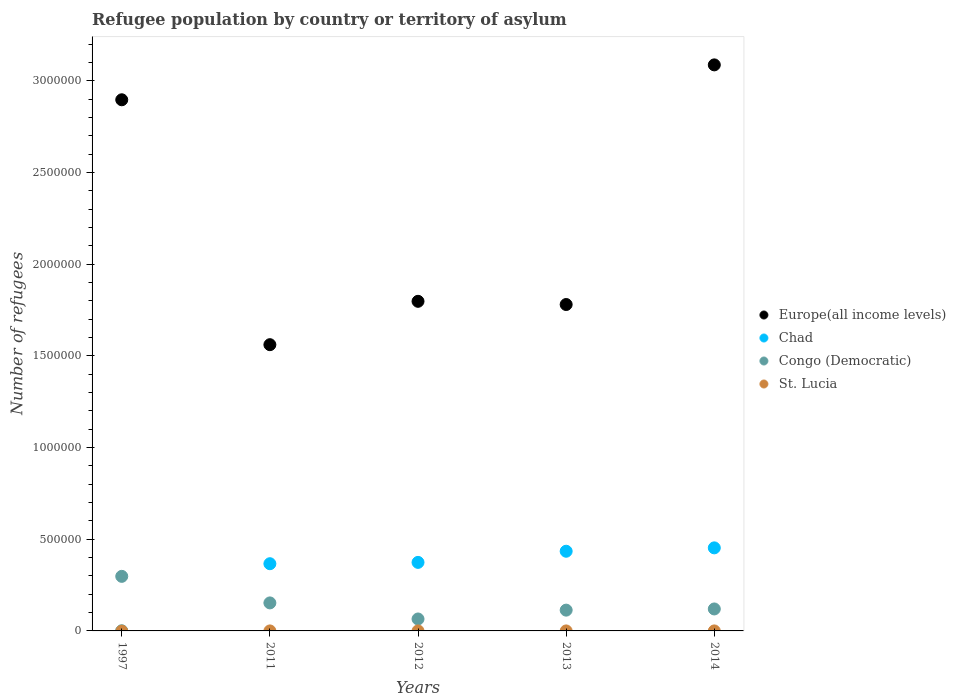How many different coloured dotlines are there?
Ensure brevity in your answer.  4. What is the number of refugees in Chad in 2013?
Provide a succinct answer. 4.34e+05. Across all years, what is the maximum number of refugees in Congo (Democratic)?
Offer a very short reply. 2.98e+05. Across all years, what is the minimum number of refugees in Congo (Democratic)?
Offer a very short reply. 6.51e+04. In which year was the number of refugees in Chad minimum?
Provide a succinct answer. 1997. What is the total number of refugees in Congo (Democratic) in the graph?
Give a very brief answer. 7.49e+05. What is the difference between the number of refugees in Chad in 2011 and that in 2014?
Offer a very short reply. -8.64e+04. What is the difference between the number of refugees in Congo (Democratic) in 2011 and the number of refugees in Europe(all income levels) in 2013?
Your answer should be very brief. -1.63e+06. What is the average number of refugees in St. Lucia per year?
Offer a terse response. 3. In the year 2011, what is the difference between the number of refugees in Congo (Democratic) and number of refugees in St. Lucia?
Your answer should be very brief. 1.53e+05. In how many years, is the number of refugees in Europe(all income levels) greater than 1400000?
Give a very brief answer. 5. What is the ratio of the number of refugees in Congo (Democratic) in 1997 to that in 2013?
Your response must be concise. 2.62. Is the difference between the number of refugees in Congo (Democratic) in 1997 and 2011 greater than the difference between the number of refugees in St. Lucia in 1997 and 2011?
Your response must be concise. Yes. What is the difference between the highest and the second highest number of refugees in Congo (Democratic)?
Ensure brevity in your answer.  1.45e+05. What is the difference between the highest and the lowest number of refugees in Europe(all income levels)?
Your answer should be compact. 1.53e+06. Is the sum of the number of refugees in Congo (Democratic) in 2011 and 2014 greater than the maximum number of refugees in St. Lucia across all years?
Provide a succinct answer. Yes. Is it the case that in every year, the sum of the number of refugees in St. Lucia and number of refugees in Congo (Democratic)  is greater than the sum of number of refugees in Europe(all income levels) and number of refugees in Chad?
Offer a very short reply. Yes. Is it the case that in every year, the sum of the number of refugees in Chad and number of refugees in St. Lucia  is greater than the number of refugees in Europe(all income levels)?
Your response must be concise. No. Is the number of refugees in St. Lucia strictly less than the number of refugees in Congo (Democratic) over the years?
Make the answer very short. Yes. How many years are there in the graph?
Give a very brief answer. 5. What is the difference between two consecutive major ticks on the Y-axis?
Provide a short and direct response. 5.00e+05. Does the graph contain any zero values?
Ensure brevity in your answer.  No. Does the graph contain grids?
Provide a succinct answer. No. Where does the legend appear in the graph?
Give a very brief answer. Center right. How many legend labels are there?
Your response must be concise. 4. What is the title of the graph?
Offer a terse response. Refugee population by country or territory of asylum. Does "Euro area" appear as one of the legend labels in the graph?
Your answer should be very brief. No. What is the label or title of the Y-axis?
Provide a succinct answer. Number of refugees. What is the Number of refugees of Europe(all income levels) in 1997?
Offer a terse response. 2.90e+06. What is the Number of refugees of Chad in 1997?
Offer a terse response. 302. What is the Number of refugees of Congo (Democratic) in 1997?
Your response must be concise. 2.98e+05. What is the Number of refugees in Europe(all income levels) in 2011?
Your answer should be compact. 1.56e+06. What is the Number of refugees of Chad in 2011?
Provide a succinct answer. 3.66e+05. What is the Number of refugees in Congo (Democratic) in 2011?
Offer a very short reply. 1.53e+05. What is the Number of refugees of Europe(all income levels) in 2012?
Your answer should be very brief. 1.80e+06. What is the Number of refugees of Chad in 2012?
Provide a succinct answer. 3.74e+05. What is the Number of refugees in Congo (Democratic) in 2012?
Your answer should be very brief. 6.51e+04. What is the Number of refugees in Europe(all income levels) in 2013?
Your answer should be very brief. 1.78e+06. What is the Number of refugees in Chad in 2013?
Provide a succinct answer. 4.34e+05. What is the Number of refugees in Congo (Democratic) in 2013?
Make the answer very short. 1.13e+05. What is the Number of refugees of St. Lucia in 2013?
Your answer should be very brief. 5. What is the Number of refugees of Europe(all income levels) in 2014?
Provide a succinct answer. 3.09e+06. What is the Number of refugees in Chad in 2014?
Keep it short and to the point. 4.53e+05. What is the Number of refugees in Congo (Democratic) in 2014?
Your answer should be very brief. 1.20e+05. Across all years, what is the maximum Number of refugees in Europe(all income levels)?
Provide a short and direct response. 3.09e+06. Across all years, what is the maximum Number of refugees in Chad?
Your response must be concise. 4.53e+05. Across all years, what is the maximum Number of refugees of Congo (Democratic)?
Keep it short and to the point. 2.98e+05. Across all years, what is the minimum Number of refugees in Europe(all income levels)?
Make the answer very short. 1.56e+06. Across all years, what is the minimum Number of refugees in Chad?
Make the answer very short. 302. Across all years, what is the minimum Number of refugees in Congo (Democratic)?
Provide a succinct answer. 6.51e+04. What is the total Number of refugees in Europe(all income levels) in the graph?
Offer a very short reply. 1.11e+07. What is the total Number of refugees in Chad in the graph?
Give a very brief answer. 1.63e+06. What is the total Number of refugees in Congo (Democratic) in the graph?
Keep it short and to the point. 7.49e+05. What is the total Number of refugees in St. Lucia in the graph?
Your response must be concise. 15. What is the difference between the Number of refugees of Europe(all income levels) in 1997 and that in 2011?
Keep it short and to the point. 1.34e+06. What is the difference between the Number of refugees in Chad in 1997 and that in 2011?
Ensure brevity in your answer.  -3.66e+05. What is the difference between the Number of refugees in Congo (Democratic) in 1997 and that in 2011?
Provide a succinct answer. 1.45e+05. What is the difference between the Number of refugees in St. Lucia in 1997 and that in 2011?
Keep it short and to the point. 1. What is the difference between the Number of refugees of Europe(all income levels) in 1997 and that in 2012?
Ensure brevity in your answer.  1.10e+06. What is the difference between the Number of refugees of Chad in 1997 and that in 2012?
Give a very brief answer. -3.73e+05. What is the difference between the Number of refugees of Congo (Democratic) in 1997 and that in 2012?
Offer a terse response. 2.32e+05. What is the difference between the Number of refugees of St. Lucia in 1997 and that in 2012?
Provide a succinct answer. 1. What is the difference between the Number of refugees of Europe(all income levels) in 1997 and that in 2013?
Provide a succinct answer. 1.12e+06. What is the difference between the Number of refugees of Chad in 1997 and that in 2013?
Offer a terse response. -4.34e+05. What is the difference between the Number of refugees of Congo (Democratic) in 1997 and that in 2013?
Provide a succinct answer. 1.84e+05. What is the difference between the Number of refugees of St. Lucia in 1997 and that in 2013?
Offer a very short reply. -2. What is the difference between the Number of refugees in Europe(all income levels) in 1997 and that in 2014?
Offer a very short reply. -1.90e+05. What is the difference between the Number of refugees of Chad in 1997 and that in 2014?
Your answer should be very brief. -4.53e+05. What is the difference between the Number of refugees of Congo (Democratic) in 1997 and that in 2014?
Keep it short and to the point. 1.78e+05. What is the difference between the Number of refugees of Europe(all income levels) in 2011 and that in 2012?
Provide a short and direct response. -2.36e+05. What is the difference between the Number of refugees in Chad in 2011 and that in 2012?
Provide a short and direct response. -7201. What is the difference between the Number of refugees of Congo (Democratic) in 2011 and that in 2012?
Your answer should be compact. 8.76e+04. What is the difference between the Number of refugees of Europe(all income levels) in 2011 and that in 2013?
Offer a terse response. -2.19e+05. What is the difference between the Number of refugees in Chad in 2011 and that in 2013?
Make the answer very short. -6.80e+04. What is the difference between the Number of refugees of Congo (Democratic) in 2011 and that in 2013?
Provide a succinct answer. 3.94e+04. What is the difference between the Number of refugees in St. Lucia in 2011 and that in 2013?
Ensure brevity in your answer.  -3. What is the difference between the Number of refugees of Europe(all income levels) in 2011 and that in 2014?
Offer a terse response. -1.53e+06. What is the difference between the Number of refugees in Chad in 2011 and that in 2014?
Keep it short and to the point. -8.64e+04. What is the difference between the Number of refugees in Congo (Democratic) in 2011 and that in 2014?
Make the answer very short. 3.30e+04. What is the difference between the Number of refugees of St. Lucia in 2011 and that in 2014?
Give a very brief answer. -1. What is the difference between the Number of refugees in Europe(all income levels) in 2012 and that in 2013?
Your answer should be compact. 1.74e+04. What is the difference between the Number of refugees of Chad in 2012 and that in 2013?
Offer a terse response. -6.08e+04. What is the difference between the Number of refugees of Congo (Democratic) in 2012 and that in 2013?
Offer a very short reply. -4.83e+04. What is the difference between the Number of refugees of St. Lucia in 2012 and that in 2013?
Provide a short and direct response. -3. What is the difference between the Number of refugees of Europe(all income levels) in 2012 and that in 2014?
Make the answer very short. -1.29e+06. What is the difference between the Number of refugees of Chad in 2012 and that in 2014?
Provide a short and direct response. -7.92e+04. What is the difference between the Number of refugees in Congo (Democratic) in 2012 and that in 2014?
Your response must be concise. -5.46e+04. What is the difference between the Number of refugees in Europe(all income levels) in 2013 and that in 2014?
Make the answer very short. -1.31e+06. What is the difference between the Number of refugees of Chad in 2013 and that in 2014?
Give a very brief answer. -1.84e+04. What is the difference between the Number of refugees in Congo (Democratic) in 2013 and that in 2014?
Offer a very short reply. -6392. What is the difference between the Number of refugees of Europe(all income levels) in 1997 and the Number of refugees of Chad in 2011?
Keep it short and to the point. 2.53e+06. What is the difference between the Number of refugees of Europe(all income levels) in 1997 and the Number of refugees of Congo (Democratic) in 2011?
Ensure brevity in your answer.  2.74e+06. What is the difference between the Number of refugees of Europe(all income levels) in 1997 and the Number of refugees of St. Lucia in 2011?
Offer a terse response. 2.90e+06. What is the difference between the Number of refugees in Chad in 1997 and the Number of refugees in Congo (Democratic) in 2011?
Ensure brevity in your answer.  -1.52e+05. What is the difference between the Number of refugees in Chad in 1997 and the Number of refugees in St. Lucia in 2011?
Ensure brevity in your answer.  300. What is the difference between the Number of refugees in Congo (Democratic) in 1997 and the Number of refugees in St. Lucia in 2011?
Ensure brevity in your answer.  2.98e+05. What is the difference between the Number of refugees in Europe(all income levels) in 1997 and the Number of refugees in Chad in 2012?
Your answer should be very brief. 2.52e+06. What is the difference between the Number of refugees in Europe(all income levels) in 1997 and the Number of refugees in Congo (Democratic) in 2012?
Give a very brief answer. 2.83e+06. What is the difference between the Number of refugees in Europe(all income levels) in 1997 and the Number of refugees in St. Lucia in 2012?
Your answer should be compact. 2.90e+06. What is the difference between the Number of refugees in Chad in 1997 and the Number of refugees in Congo (Democratic) in 2012?
Your response must be concise. -6.48e+04. What is the difference between the Number of refugees of Chad in 1997 and the Number of refugees of St. Lucia in 2012?
Your response must be concise. 300. What is the difference between the Number of refugees of Congo (Democratic) in 1997 and the Number of refugees of St. Lucia in 2012?
Offer a terse response. 2.98e+05. What is the difference between the Number of refugees in Europe(all income levels) in 1997 and the Number of refugees in Chad in 2013?
Provide a short and direct response. 2.46e+06. What is the difference between the Number of refugees in Europe(all income levels) in 1997 and the Number of refugees in Congo (Democratic) in 2013?
Offer a very short reply. 2.78e+06. What is the difference between the Number of refugees in Europe(all income levels) in 1997 and the Number of refugees in St. Lucia in 2013?
Offer a very short reply. 2.90e+06. What is the difference between the Number of refugees of Chad in 1997 and the Number of refugees of Congo (Democratic) in 2013?
Make the answer very short. -1.13e+05. What is the difference between the Number of refugees of Chad in 1997 and the Number of refugees of St. Lucia in 2013?
Ensure brevity in your answer.  297. What is the difference between the Number of refugees in Congo (Democratic) in 1997 and the Number of refugees in St. Lucia in 2013?
Offer a very short reply. 2.98e+05. What is the difference between the Number of refugees of Europe(all income levels) in 1997 and the Number of refugees of Chad in 2014?
Offer a terse response. 2.44e+06. What is the difference between the Number of refugees in Europe(all income levels) in 1997 and the Number of refugees in Congo (Democratic) in 2014?
Your response must be concise. 2.78e+06. What is the difference between the Number of refugees of Europe(all income levels) in 1997 and the Number of refugees of St. Lucia in 2014?
Give a very brief answer. 2.90e+06. What is the difference between the Number of refugees in Chad in 1997 and the Number of refugees in Congo (Democratic) in 2014?
Your answer should be compact. -1.19e+05. What is the difference between the Number of refugees in Chad in 1997 and the Number of refugees in St. Lucia in 2014?
Offer a very short reply. 299. What is the difference between the Number of refugees in Congo (Democratic) in 1997 and the Number of refugees in St. Lucia in 2014?
Offer a very short reply. 2.98e+05. What is the difference between the Number of refugees in Europe(all income levels) in 2011 and the Number of refugees in Chad in 2012?
Offer a terse response. 1.19e+06. What is the difference between the Number of refugees in Europe(all income levels) in 2011 and the Number of refugees in Congo (Democratic) in 2012?
Your answer should be very brief. 1.50e+06. What is the difference between the Number of refugees of Europe(all income levels) in 2011 and the Number of refugees of St. Lucia in 2012?
Provide a short and direct response. 1.56e+06. What is the difference between the Number of refugees of Chad in 2011 and the Number of refugees of Congo (Democratic) in 2012?
Offer a terse response. 3.01e+05. What is the difference between the Number of refugees of Chad in 2011 and the Number of refugees of St. Lucia in 2012?
Your answer should be very brief. 3.66e+05. What is the difference between the Number of refugees in Congo (Democratic) in 2011 and the Number of refugees in St. Lucia in 2012?
Make the answer very short. 1.53e+05. What is the difference between the Number of refugees of Europe(all income levels) in 2011 and the Number of refugees of Chad in 2013?
Your response must be concise. 1.13e+06. What is the difference between the Number of refugees in Europe(all income levels) in 2011 and the Number of refugees in Congo (Democratic) in 2013?
Your answer should be compact. 1.45e+06. What is the difference between the Number of refugees in Europe(all income levels) in 2011 and the Number of refugees in St. Lucia in 2013?
Provide a succinct answer. 1.56e+06. What is the difference between the Number of refugees in Chad in 2011 and the Number of refugees in Congo (Democratic) in 2013?
Ensure brevity in your answer.  2.53e+05. What is the difference between the Number of refugees of Chad in 2011 and the Number of refugees of St. Lucia in 2013?
Give a very brief answer. 3.66e+05. What is the difference between the Number of refugees of Congo (Democratic) in 2011 and the Number of refugees of St. Lucia in 2013?
Provide a succinct answer. 1.53e+05. What is the difference between the Number of refugees of Europe(all income levels) in 2011 and the Number of refugees of Chad in 2014?
Make the answer very short. 1.11e+06. What is the difference between the Number of refugees of Europe(all income levels) in 2011 and the Number of refugees of Congo (Democratic) in 2014?
Provide a short and direct response. 1.44e+06. What is the difference between the Number of refugees in Europe(all income levels) in 2011 and the Number of refugees in St. Lucia in 2014?
Offer a terse response. 1.56e+06. What is the difference between the Number of refugees in Chad in 2011 and the Number of refugees in Congo (Democratic) in 2014?
Give a very brief answer. 2.47e+05. What is the difference between the Number of refugees of Chad in 2011 and the Number of refugees of St. Lucia in 2014?
Offer a very short reply. 3.66e+05. What is the difference between the Number of refugees of Congo (Democratic) in 2011 and the Number of refugees of St. Lucia in 2014?
Offer a very short reply. 1.53e+05. What is the difference between the Number of refugees of Europe(all income levels) in 2012 and the Number of refugees of Chad in 2013?
Make the answer very short. 1.36e+06. What is the difference between the Number of refugees in Europe(all income levels) in 2012 and the Number of refugees in Congo (Democratic) in 2013?
Offer a terse response. 1.68e+06. What is the difference between the Number of refugees in Europe(all income levels) in 2012 and the Number of refugees in St. Lucia in 2013?
Offer a very short reply. 1.80e+06. What is the difference between the Number of refugees of Chad in 2012 and the Number of refugees of Congo (Democratic) in 2013?
Provide a short and direct response. 2.60e+05. What is the difference between the Number of refugees of Chad in 2012 and the Number of refugees of St. Lucia in 2013?
Your response must be concise. 3.74e+05. What is the difference between the Number of refugees in Congo (Democratic) in 2012 and the Number of refugees in St. Lucia in 2013?
Offer a very short reply. 6.51e+04. What is the difference between the Number of refugees in Europe(all income levels) in 2012 and the Number of refugees in Chad in 2014?
Your answer should be compact. 1.34e+06. What is the difference between the Number of refugees of Europe(all income levels) in 2012 and the Number of refugees of Congo (Democratic) in 2014?
Make the answer very short. 1.68e+06. What is the difference between the Number of refugees of Europe(all income levels) in 2012 and the Number of refugees of St. Lucia in 2014?
Make the answer very short. 1.80e+06. What is the difference between the Number of refugees in Chad in 2012 and the Number of refugees in Congo (Democratic) in 2014?
Make the answer very short. 2.54e+05. What is the difference between the Number of refugees of Chad in 2012 and the Number of refugees of St. Lucia in 2014?
Offer a very short reply. 3.74e+05. What is the difference between the Number of refugees in Congo (Democratic) in 2012 and the Number of refugees in St. Lucia in 2014?
Your answer should be compact. 6.51e+04. What is the difference between the Number of refugees of Europe(all income levels) in 2013 and the Number of refugees of Chad in 2014?
Make the answer very short. 1.33e+06. What is the difference between the Number of refugees of Europe(all income levels) in 2013 and the Number of refugees of Congo (Democratic) in 2014?
Make the answer very short. 1.66e+06. What is the difference between the Number of refugees of Europe(all income levels) in 2013 and the Number of refugees of St. Lucia in 2014?
Your answer should be very brief. 1.78e+06. What is the difference between the Number of refugees in Chad in 2013 and the Number of refugees in Congo (Democratic) in 2014?
Keep it short and to the point. 3.15e+05. What is the difference between the Number of refugees of Chad in 2013 and the Number of refugees of St. Lucia in 2014?
Your answer should be compact. 4.34e+05. What is the difference between the Number of refugees of Congo (Democratic) in 2013 and the Number of refugees of St. Lucia in 2014?
Keep it short and to the point. 1.13e+05. What is the average Number of refugees of Europe(all income levels) per year?
Your response must be concise. 2.22e+06. What is the average Number of refugees of Chad per year?
Offer a very short reply. 3.26e+05. What is the average Number of refugees in Congo (Democratic) per year?
Provide a short and direct response. 1.50e+05. In the year 1997, what is the difference between the Number of refugees in Europe(all income levels) and Number of refugees in Chad?
Offer a terse response. 2.90e+06. In the year 1997, what is the difference between the Number of refugees of Europe(all income levels) and Number of refugees of Congo (Democratic)?
Provide a short and direct response. 2.60e+06. In the year 1997, what is the difference between the Number of refugees in Europe(all income levels) and Number of refugees in St. Lucia?
Your answer should be compact. 2.90e+06. In the year 1997, what is the difference between the Number of refugees of Chad and Number of refugees of Congo (Democratic)?
Your answer should be very brief. -2.97e+05. In the year 1997, what is the difference between the Number of refugees of Chad and Number of refugees of St. Lucia?
Offer a terse response. 299. In the year 1997, what is the difference between the Number of refugees in Congo (Democratic) and Number of refugees in St. Lucia?
Your answer should be compact. 2.98e+05. In the year 2011, what is the difference between the Number of refugees of Europe(all income levels) and Number of refugees of Chad?
Keep it short and to the point. 1.19e+06. In the year 2011, what is the difference between the Number of refugees in Europe(all income levels) and Number of refugees in Congo (Democratic)?
Provide a succinct answer. 1.41e+06. In the year 2011, what is the difference between the Number of refugees of Europe(all income levels) and Number of refugees of St. Lucia?
Offer a terse response. 1.56e+06. In the year 2011, what is the difference between the Number of refugees in Chad and Number of refugees in Congo (Democratic)?
Offer a very short reply. 2.14e+05. In the year 2011, what is the difference between the Number of refugees in Chad and Number of refugees in St. Lucia?
Offer a terse response. 3.66e+05. In the year 2011, what is the difference between the Number of refugees in Congo (Democratic) and Number of refugees in St. Lucia?
Your response must be concise. 1.53e+05. In the year 2012, what is the difference between the Number of refugees in Europe(all income levels) and Number of refugees in Chad?
Give a very brief answer. 1.42e+06. In the year 2012, what is the difference between the Number of refugees of Europe(all income levels) and Number of refugees of Congo (Democratic)?
Make the answer very short. 1.73e+06. In the year 2012, what is the difference between the Number of refugees in Europe(all income levels) and Number of refugees in St. Lucia?
Offer a terse response. 1.80e+06. In the year 2012, what is the difference between the Number of refugees of Chad and Number of refugees of Congo (Democratic)?
Offer a terse response. 3.09e+05. In the year 2012, what is the difference between the Number of refugees of Chad and Number of refugees of St. Lucia?
Keep it short and to the point. 3.74e+05. In the year 2012, what is the difference between the Number of refugees in Congo (Democratic) and Number of refugees in St. Lucia?
Your answer should be compact. 6.51e+04. In the year 2013, what is the difference between the Number of refugees in Europe(all income levels) and Number of refugees in Chad?
Provide a short and direct response. 1.35e+06. In the year 2013, what is the difference between the Number of refugees in Europe(all income levels) and Number of refugees in Congo (Democratic)?
Offer a very short reply. 1.67e+06. In the year 2013, what is the difference between the Number of refugees in Europe(all income levels) and Number of refugees in St. Lucia?
Your response must be concise. 1.78e+06. In the year 2013, what is the difference between the Number of refugees in Chad and Number of refugees in Congo (Democratic)?
Your answer should be compact. 3.21e+05. In the year 2013, what is the difference between the Number of refugees of Chad and Number of refugees of St. Lucia?
Your answer should be very brief. 4.34e+05. In the year 2013, what is the difference between the Number of refugees in Congo (Democratic) and Number of refugees in St. Lucia?
Provide a succinct answer. 1.13e+05. In the year 2014, what is the difference between the Number of refugees in Europe(all income levels) and Number of refugees in Chad?
Your answer should be compact. 2.63e+06. In the year 2014, what is the difference between the Number of refugees in Europe(all income levels) and Number of refugees in Congo (Democratic)?
Offer a terse response. 2.97e+06. In the year 2014, what is the difference between the Number of refugees of Europe(all income levels) and Number of refugees of St. Lucia?
Offer a terse response. 3.09e+06. In the year 2014, what is the difference between the Number of refugees of Chad and Number of refugees of Congo (Democratic)?
Your answer should be very brief. 3.33e+05. In the year 2014, what is the difference between the Number of refugees in Chad and Number of refugees in St. Lucia?
Provide a succinct answer. 4.53e+05. In the year 2014, what is the difference between the Number of refugees in Congo (Democratic) and Number of refugees in St. Lucia?
Your answer should be very brief. 1.20e+05. What is the ratio of the Number of refugees in Europe(all income levels) in 1997 to that in 2011?
Offer a very short reply. 1.86. What is the ratio of the Number of refugees in Chad in 1997 to that in 2011?
Provide a succinct answer. 0. What is the ratio of the Number of refugees in Congo (Democratic) in 1997 to that in 2011?
Your response must be concise. 1.95. What is the ratio of the Number of refugees in Europe(all income levels) in 1997 to that in 2012?
Offer a terse response. 1.61. What is the ratio of the Number of refugees in Chad in 1997 to that in 2012?
Provide a succinct answer. 0. What is the ratio of the Number of refugees in Congo (Democratic) in 1997 to that in 2012?
Your answer should be compact. 4.57. What is the ratio of the Number of refugees in Europe(all income levels) in 1997 to that in 2013?
Your answer should be very brief. 1.63. What is the ratio of the Number of refugees of Chad in 1997 to that in 2013?
Your response must be concise. 0. What is the ratio of the Number of refugees in Congo (Democratic) in 1997 to that in 2013?
Provide a succinct answer. 2.62. What is the ratio of the Number of refugees in Europe(all income levels) in 1997 to that in 2014?
Your answer should be compact. 0.94. What is the ratio of the Number of refugees in Chad in 1997 to that in 2014?
Keep it short and to the point. 0. What is the ratio of the Number of refugees of Congo (Democratic) in 1997 to that in 2014?
Offer a very short reply. 2.48. What is the ratio of the Number of refugees in Europe(all income levels) in 2011 to that in 2012?
Your answer should be very brief. 0.87. What is the ratio of the Number of refugees of Chad in 2011 to that in 2012?
Your answer should be very brief. 0.98. What is the ratio of the Number of refugees of Congo (Democratic) in 2011 to that in 2012?
Provide a succinct answer. 2.35. What is the ratio of the Number of refugees of Europe(all income levels) in 2011 to that in 2013?
Provide a succinct answer. 0.88. What is the ratio of the Number of refugees in Chad in 2011 to that in 2013?
Provide a short and direct response. 0.84. What is the ratio of the Number of refugees of Congo (Democratic) in 2011 to that in 2013?
Your answer should be compact. 1.35. What is the ratio of the Number of refugees in Europe(all income levels) in 2011 to that in 2014?
Your answer should be compact. 0.51. What is the ratio of the Number of refugees of Chad in 2011 to that in 2014?
Your answer should be compact. 0.81. What is the ratio of the Number of refugees in Congo (Democratic) in 2011 to that in 2014?
Your answer should be compact. 1.28. What is the ratio of the Number of refugees in St. Lucia in 2011 to that in 2014?
Provide a short and direct response. 0.67. What is the ratio of the Number of refugees in Europe(all income levels) in 2012 to that in 2013?
Give a very brief answer. 1.01. What is the ratio of the Number of refugees in Chad in 2012 to that in 2013?
Keep it short and to the point. 0.86. What is the ratio of the Number of refugees in Congo (Democratic) in 2012 to that in 2013?
Offer a very short reply. 0.57. What is the ratio of the Number of refugees in St. Lucia in 2012 to that in 2013?
Offer a very short reply. 0.4. What is the ratio of the Number of refugees in Europe(all income levels) in 2012 to that in 2014?
Your response must be concise. 0.58. What is the ratio of the Number of refugees of Chad in 2012 to that in 2014?
Provide a short and direct response. 0.83. What is the ratio of the Number of refugees in Congo (Democratic) in 2012 to that in 2014?
Offer a very short reply. 0.54. What is the ratio of the Number of refugees in Europe(all income levels) in 2013 to that in 2014?
Offer a very short reply. 0.58. What is the ratio of the Number of refugees in Chad in 2013 to that in 2014?
Offer a terse response. 0.96. What is the ratio of the Number of refugees in Congo (Democratic) in 2013 to that in 2014?
Keep it short and to the point. 0.95. What is the difference between the highest and the second highest Number of refugees of Europe(all income levels)?
Ensure brevity in your answer.  1.90e+05. What is the difference between the highest and the second highest Number of refugees in Chad?
Provide a short and direct response. 1.84e+04. What is the difference between the highest and the second highest Number of refugees of Congo (Democratic)?
Provide a short and direct response. 1.45e+05. What is the difference between the highest and the second highest Number of refugees of St. Lucia?
Your response must be concise. 2. What is the difference between the highest and the lowest Number of refugees of Europe(all income levels)?
Provide a short and direct response. 1.53e+06. What is the difference between the highest and the lowest Number of refugees of Chad?
Offer a terse response. 4.53e+05. What is the difference between the highest and the lowest Number of refugees of Congo (Democratic)?
Ensure brevity in your answer.  2.32e+05. 